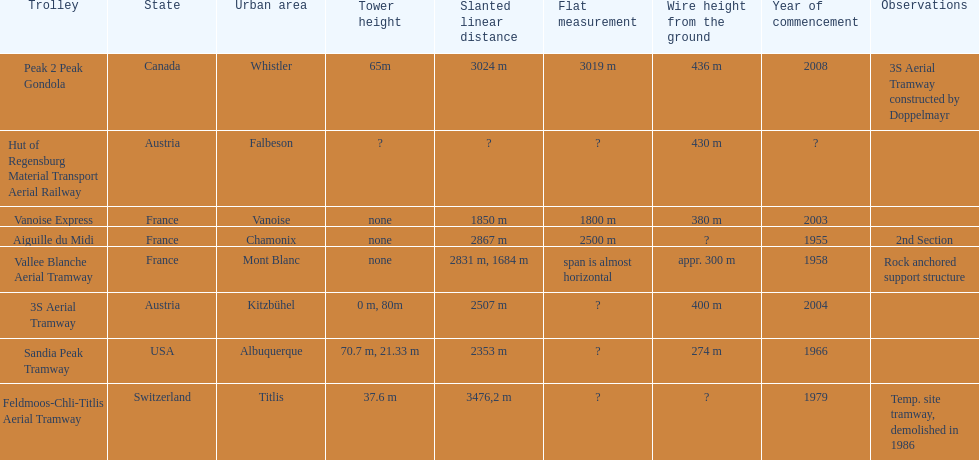How much greater is the height of cable over ground measurement for the peak 2 peak gondola when compared with that of the vanoise express? 56 m. 